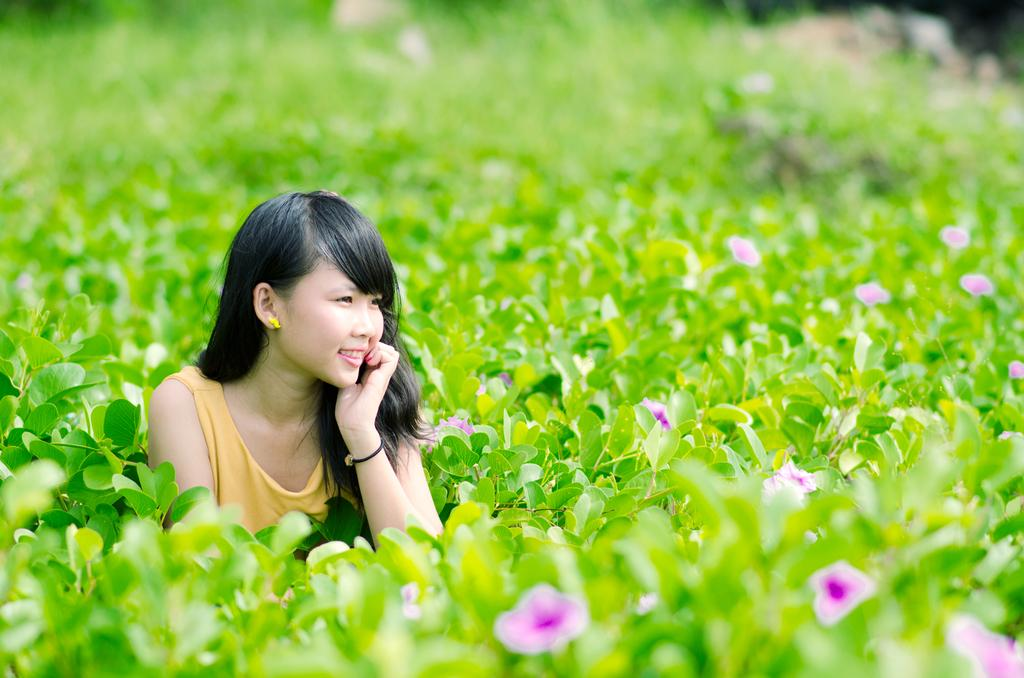Who is present in the image? There is a woman in the image. Where is the woman located in the image? The woman is on the left side of the image. What expression does the woman have? The woman has a pretty smile on her face. What type of plants can be seen in the image? There are flowering plants and green leaves in the image. How does the wind blow the woman's hair in the image? There is no wind blowing the woman's hair in the image; her hair is not depicted as moving. 